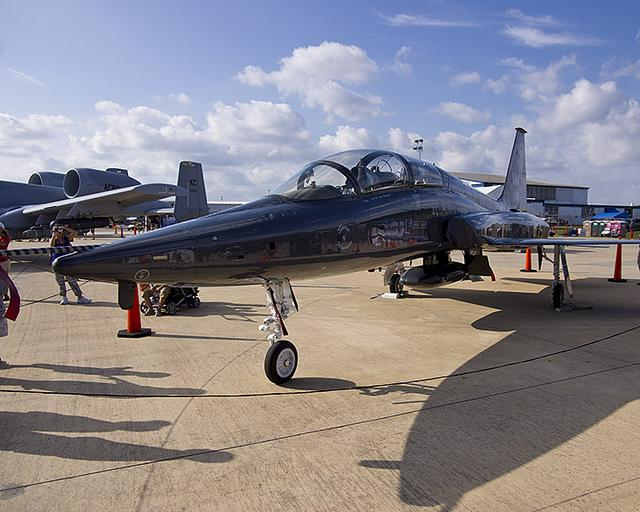Why is the plane parked here?

Choices:
A) cleaning
B) on display
C) maintenance
D) for sale on display 